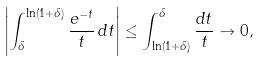Convert formula to latex. <formula><loc_0><loc_0><loc_500><loc_500>\left | \int _ { \delta } ^ { \ln ( 1 + \delta ) } \frac { e ^ { - t } } { t } \, d t \right | \leq \int _ { \ln ( 1 + \delta ) } ^ { \delta } \frac { d t } { t } \to 0 ,</formula> 